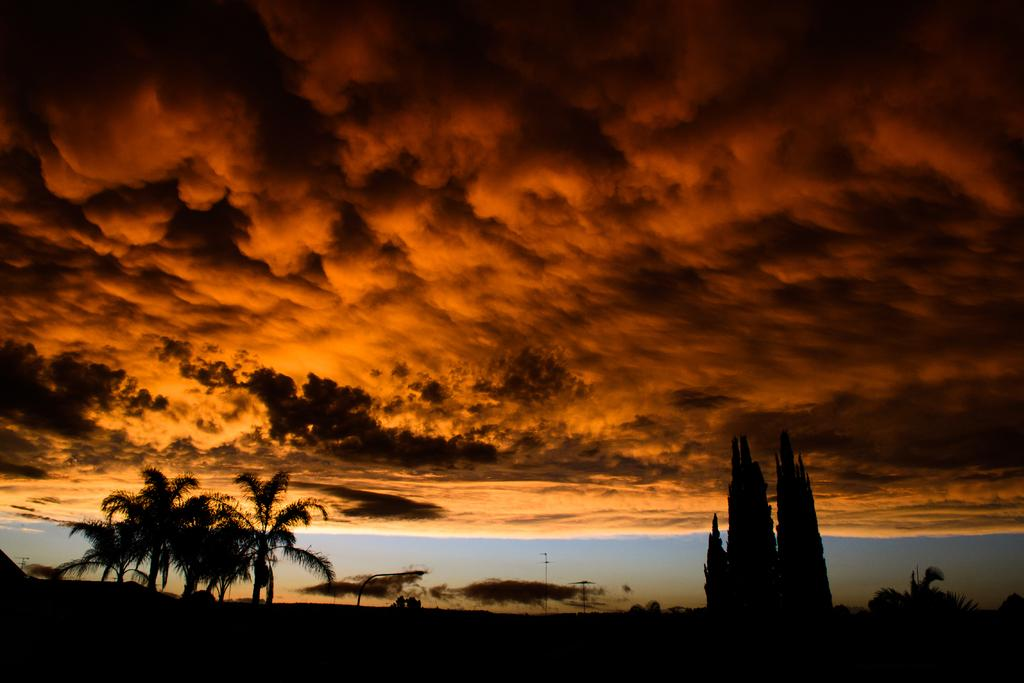What is the lighting condition in the image? The image was taken in the dark. What can be seen at the bottom of the image? There are trees at the bottom of the image. What is visible at the top of the image? The sky is visible at the top of the image. What can be observed in the sky? Clouds are present in the sky. What type of leather is being tested in the image? There is no leather or testing activity present in the image. How many eggs are visible in the image? There are no eggs visible in the image. 